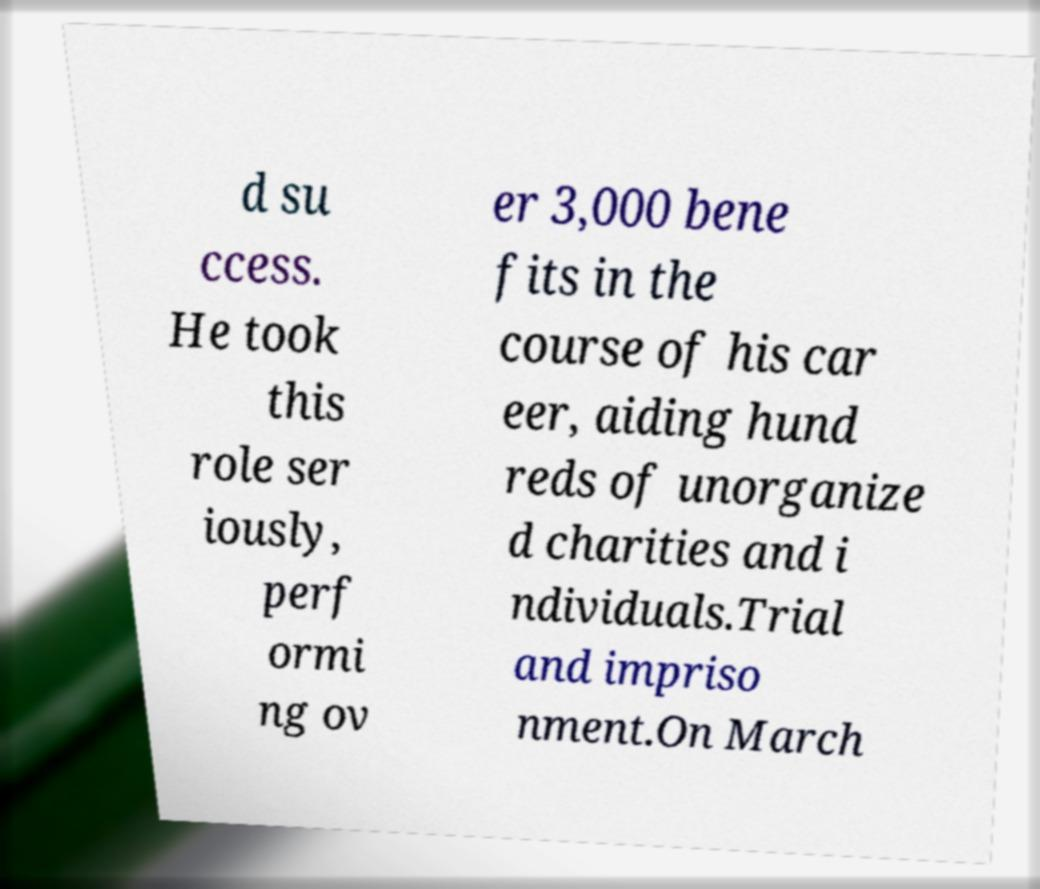Could you extract and type out the text from this image? d su ccess. He took this role ser iously, perf ormi ng ov er 3,000 bene fits in the course of his car eer, aiding hund reds of unorganize d charities and i ndividuals.Trial and impriso nment.On March 